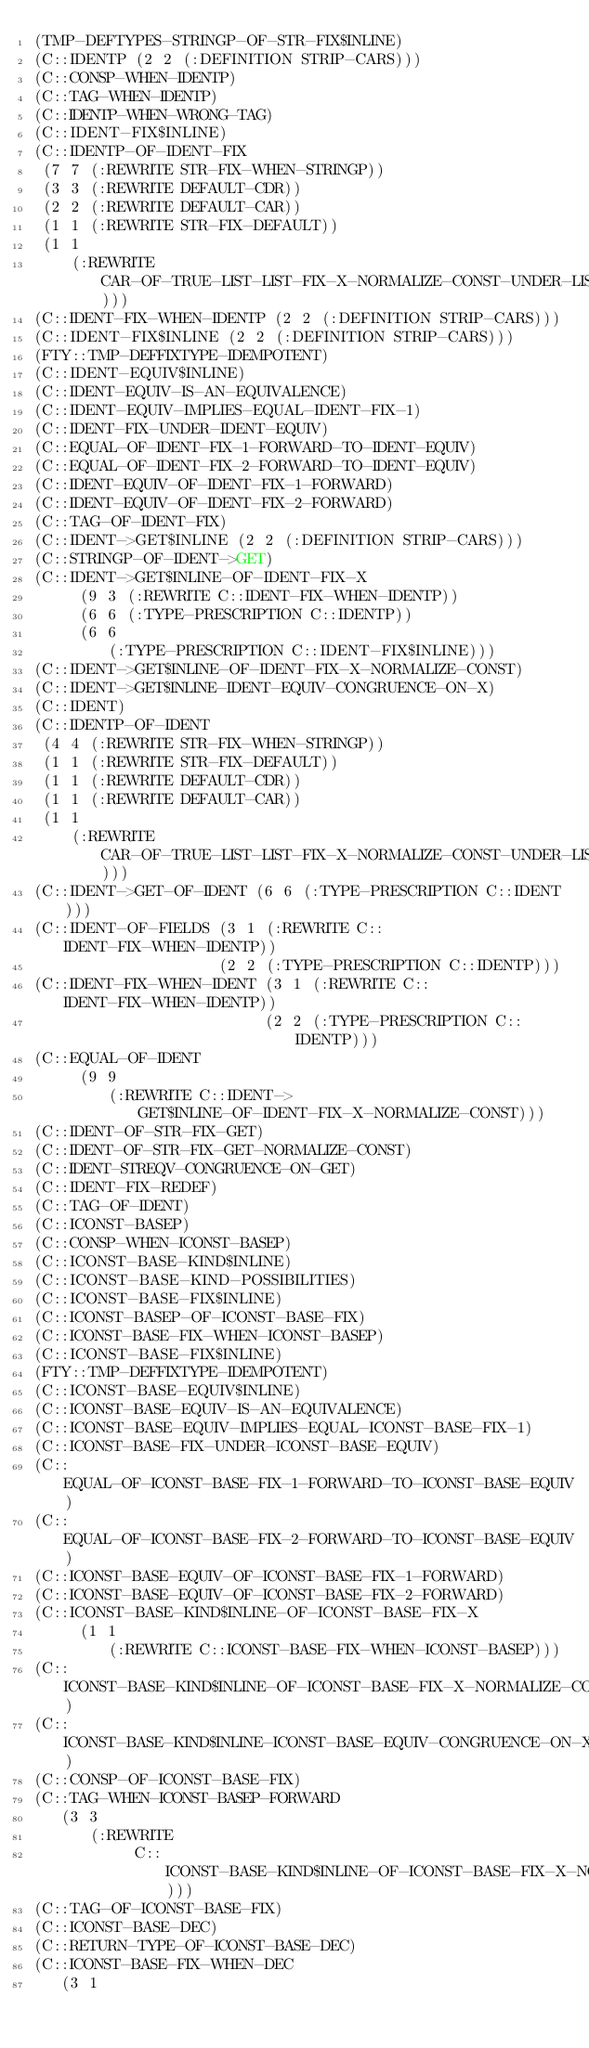Convert code to text. <code><loc_0><loc_0><loc_500><loc_500><_Lisp_>(TMP-DEFTYPES-STRINGP-OF-STR-FIX$INLINE)
(C::IDENTP (2 2 (:DEFINITION STRIP-CARS)))
(C::CONSP-WHEN-IDENTP)
(C::TAG-WHEN-IDENTP)
(C::IDENTP-WHEN-WRONG-TAG)
(C::IDENT-FIX$INLINE)
(C::IDENTP-OF-IDENT-FIX
 (7 7 (:REWRITE STR-FIX-WHEN-STRINGP))
 (3 3 (:REWRITE DEFAULT-CDR))
 (2 2 (:REWRITE DEFAULT-CAR))
 (1 1 (:REWRITE STR-FIX-DEFAULT))
 (1 1
    (:REWRITE CAR-OF-TRUE-LIST-LIST-FIX-X-NORMALIZE-CONST-UNDER-LIST-EQUIV)))
(C::IDENT-FIX-WHEN-IDENTP (2 2 (:DEFINITION STRIP-CARS)))
(C::IDENT-FIX$INLINE (2 2 (:DEFINITION STRIP-CARS)))
(FTY::TMP-DEFFIXTYPE-IDEMPOTENT)
(C::IDENT-EQUIV$INLINE)
(C::IDENT-EQUIV-IS-AN-EQUIVALENCE)
(C::IDENT-EQUIV-IMPLIES-EQUAL-IDENT-FIX-1)
(C::IDENT-FIX-UNDER-IDENT-EQUIV)
(C::EQUAL-OF-IDENT-FIX-1-FORWARD-TO-IDENT-EQUIV)
(C::EQUAL-OF-IDENT-FIX-2-FORWARD-TO-IDENT-EQUIV)
(C::IDENT-EQUIV-OF-IDENT-FIX-1-FORWARD)
(C::IDENT-EQUIV-OF-IDENT-FIX-2-FORWARD)
(C::TAG-OF-IDENT-FIX)
(C::IDENT->GET$INLINE (2 2 (:DEFINITION STRIP-CARS)))
(C::STRINGP-OF-IDENT->GET)
(C::IDENT->GET$INLINE-OF-IDENT-FIX-X
     (9 3 (:REWRITE C::IDENT-FIX-WHEN-IDENTP))
     (6 6 (:TYPE-PRESCRIPTION C::IDENTP))
     (6 6
        (:TYPE-PRESCRIPTION C::IDENT-FIX$INLINE)))
(C::IDENT->GET$INLINE-OF-IDENT-FIX-X-NORMALIZE-CONST)
(C::IDENT->GET$INLINE-IDENT-EQUIV-CONGRUENCE-ON-X)
(C::IDENT)
(C::IDENTP-OF-IDENT
 (4 4 (:REWRITE STR-FIX-WHEN-STRINGP))
 (1 1 (:REWRITE STR-FIX-DEFAULT))
 (1 1 (:REWRITE DEFAULT-CDR))
 (1 1 (:REWRITE DEFAULT-CAR))
 (1 1
    (:REWRITE CAR-OF-TRUE-LIST-LIST-FIX-X-NORMALIZE-CONST-UNDER-LIST-EQUIV)))
(C::IDENT->GET-OF-IDENT (6 6 (:TYPE-PRESCRIPTION C::IDENT)))
(C::IDENT-OF-FIELDS (3 1 (:REWRITE C::IDENT-FIX-WHEN-IDENTP))
                    (2 2 (:TYPE-PRESCRIPTION C::IDENTP)))
(C::IDENT-FIX-WHEN-IDENT (3 1 (:REWRITE C::IDENT-FIX-WHEN-IDENTP))
                         (2 2 (:TYPE-PRESCRIPTION C::IDENTP)))
(C::EQUAL-OF-IDENT
     (9 9
        (:REWRITE C::IDENT->GET$INLINE-OF-IDENT-FIX-X-NORMALIZE-CONST)))
(C::IDENT-OF-STR-FIX-GET)
(C::IDENT-OF-STR-FIX-GET-NORMALIZE-CONST)
(C::IDENT-STREQV-CONGRUENCE-ON-GET)
(C::IDENT-FIX-REDEF)
(C::TAG-OF-IDENT)
(C::ICONST-BASEP)
(C::CONSP-WHEN-ICONST-BASEP)
(C::ICONST-BASE-KIND$INLINE)
(C::ICONST-BASE-KIND-POSSIBILITIES)
(C::ICONST-BASE-FIX$INLINE)
(C::ICONST-BASEP-OF-ICONST-BASE-FIX)
(C::ICONST-BASE-FIX-WHEN-ICONST-BASEP)
(C::ICONST-BASE-FIX$INLINE)
(FTY::TMP-DEFFIXTYPE-IDEMPOTENT)
(C::ICONST-BASE-EQUIV$INLINE)
(C::ICONST-BASE-EQUIV-IS-AN-EQUIVALENCE)
(C::ICONST-BASE-EQUIV-IMPLIES-EQUAL-ICONST-BASE-FIX-1)
(C::ICONST-BASE-FIX-UNDER-ICONST-BASE-EQUIV)
(C::EQUAL-OF-ICONST-BASE-FIX-1-FORWARD-TO-ICONST-BASE-EQUIV)
(C::EQUAL-OF-ICONST-BASE-FIX-2-FORWARD-TO-ICONST-BASE-EQUIV)
(C::ICONST-BASE-EQUIV-OF-ICONST-BASE-FIX-1-FORWARD)
(C::ICONST-BASE-EQUIV-OF-ICONST-BASE-FIX-2-FORWARD)
(C::ICONST-BASE-KIND$INLINE-OF-ICONST-BASE-FIX-X
     (1 1
        (:REWRITE C::ICONST-BASE-FIX-WHEN-ICONST-BASEP)))
(C::ICONST-BASE-KIND$INLINE-OF-ICONST-BASE-FIX-X-NORMALIZE-CONST)
(C::ICONST-BASE-KIND$INLINE-ICONST-BASE-EQUIV-CONGRUENCE-ON-X)
(C::CONSP-OF-ICONST-BASE-FIX)
(C::TAG-WHEN-ICONST-BASEP-FORWARD
   (3 3
      (:REWRITE
           C::ICONST-BASE-KIND$INLINE-OF-ICONST-BASE-FIX-X-NORMALIZE-CONST)))
(C::TAG-OF-ICONST-BASE-FIX)
(C::ICONST-BASE-DEC)
(C::RETURN-TYPE-OF-ICONST-BASE-DEC)
(C::ICONST-BASE-FIX-WHEN-DEC
   (3 1</code> 